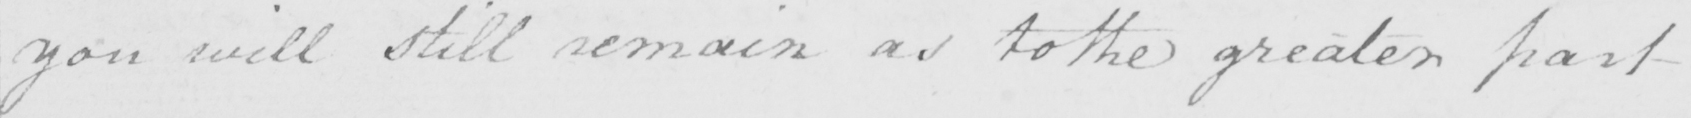Can you read and transcribe this handwriting? you will still remain as to the greater part 